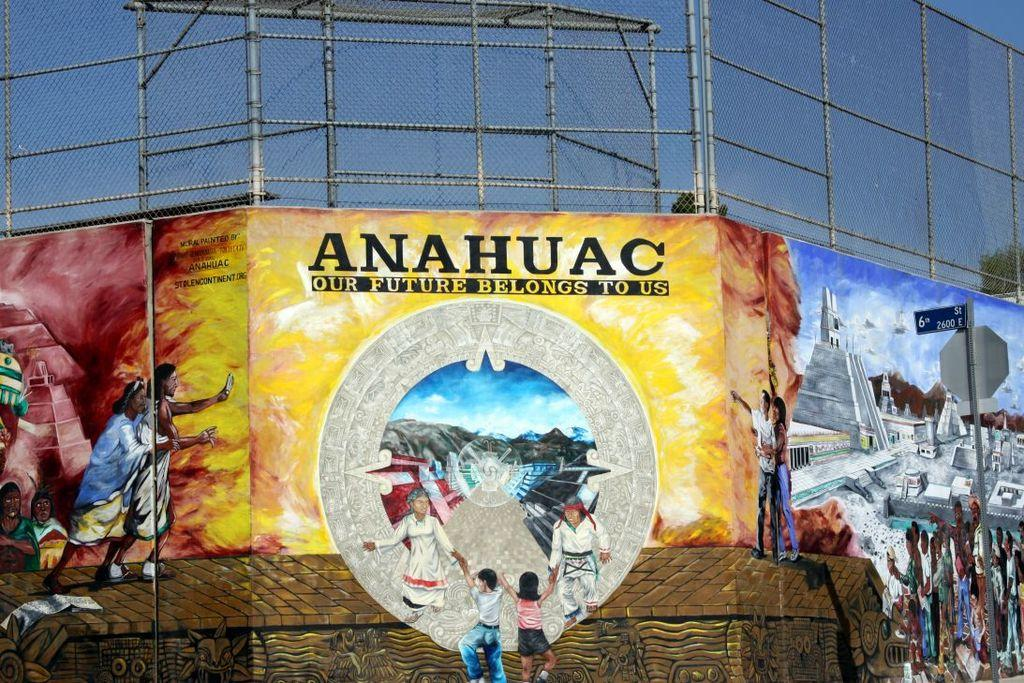<image>
Relay a brief, clear account of the picture shown. A fence for a park or little league field with a mural in front that reads "Anahuac, Our future belongs to us". 